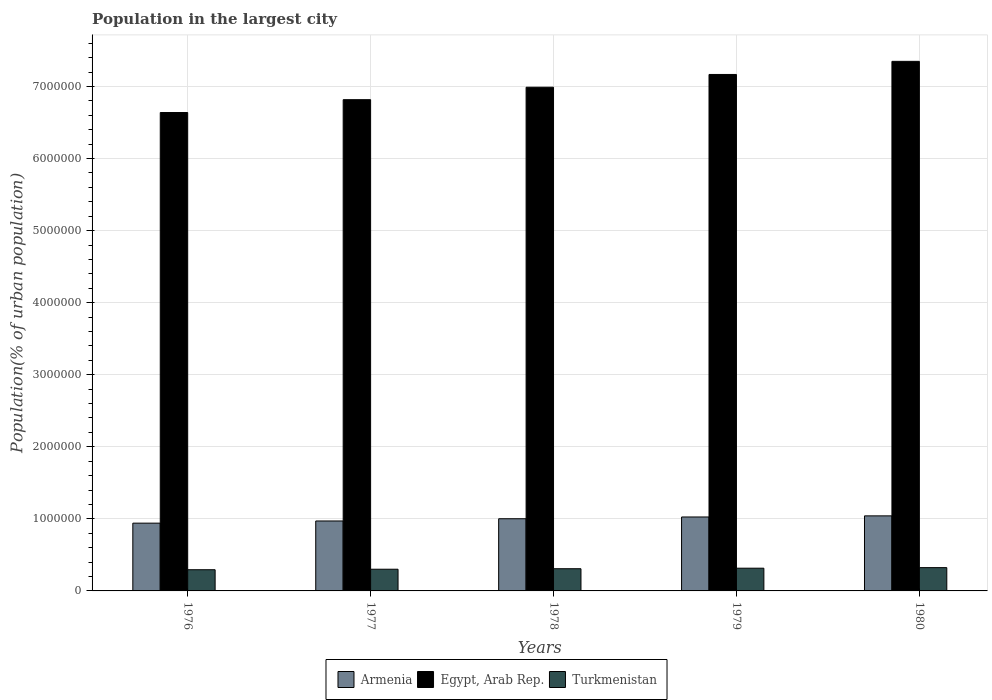How many different coloured bars are there?
Ensure brevity in your answer.  3. How many groups of bars are there?
Make the answer very short. 5. Are the number of bars per tick equal to the number of legend labels?
Your answer should be very brief. Yes. How many bars are there on the 4th tick from the left?
Offer a terse response. 3. How many bars are there on the 2nd tick from the right?
Give a very brief answer. 3. In how many cases, is the number of bars for a given year not equal to the number of legend labels?
Provide a short and direct response. 0. What is the population in the largest city in Turkmenistan in 1978?
Offer a terse response. 3.08e+05. Across all years, what is the maximum population in the largest city in Egypt, Arab Rep.?
Make the answer very short. 7.35e+06. Across all years, what is the minimum population in the largest city in Armenia?
Keep it short and to the point. 9.40e+05. In which year was the population in the largest city in Egypt, Arab Rep. minimum?
Make the answer very short. 1976. What is the total population in the largest city in Egypt, Arab Rep. in the graph?
Give a very brief answer. 3.50e+07. What is the difference between the population in the largest city in Turkmenistan in 1977 and that in 1980?
Offer a terse response. -2.22e+04. What is the difference between the population in the largest city in Turkmenistan in 1977 and the population in the largest city in Armenia in 1976?
Your answer should be very brief. -6.39e+05. What is the average population in the largest city in Egypt, Arab Rep. per year?
Make the answer very short. 6.99e+06. In the year 1976, what is the difference between the population in the largest city in Turkmenistan and population in the largest city in Egypt, Arab Rep.?
Give a very brief answer. -6.34e+06. In how many years, is the population in the largest city in Egypt, Arab Rep. greater than 4200000 %?
Keep it short and to the point. 5. What is the ratio of the population in the largest city in Turkmenistan in 1976 to that in 1978?
Keep it short and to the point. 0.95. Is the difference between the population in the largest city in Turkmenistan in 1976 and 1979 greater than the difference between the population in the largest city in Egypt, Arab Rep. in 1976 and 1979?
Keep it short and to the point. Yes. What is the difference between the highest and the second highest population in the largest city in Armenia?
Provide a succinct answer. 1.56e+04. What is the difference between the highest and the lowest population in the largest city in Egypt, Arab Rep.?
Your response must be concise. 7.10e+05. In how many years, is the population in the largest city in Armenia greater than the average population in the largest city in Armenia taken over all years?
Ensure brevity in your answer.  3. What does the 3rd bar from the left in 1980 represents?
Give a very brief answer. Turkmenistan. What does the 1st bar from the right in 1979 represents?
Offer a very short reply. Turkmenistan. Is it the case that in every year, the sum of the population in the largest city in Armenia and population in the largest city in Egypt, Arab Rep. is greater than the population in the largest city in Turkmenistan?
Give a very brief answer. Yes. Are all the bars in the graph horizontal?
Your answer should be compact. No. Are the values on the major ticks of Y-axis written in scientific E-notation?
Make the answer very short. No. Where does the legend appear in the graph?
Keep it short and to the point. Bottom center. How are the legend labels stacked?
Give a very brief answer. Horizontal. What is the title of the graph?
Your answer should be compact. Population in the largest city. What is the label or title of the X-axis?
Your response must be concise. Years. What is the label or title of the Y-axis?
Ensure brevity in your answer.  Population(% of urban population). What is the Population(% of urban population) in Armenia in 1976?
Your answer should be very brief. 9.40e+05. What is the Population(% of urban population) of Egypt, Arab Rep. in 1976?
Your response must be concise. 6.64e+06. What is the Population(% of urban population) of Turkmenistan in 1976?
Make the answer very short. 2.94e+05. What is the Population(% of urban population) of Armenia in 1977?
Make the answer very short. 9.71e+05. What is the Population(% of urban population) of Egypt, Arab Rep. in 1977?
Offer a very short reply. 6.82e+06. What is the Population(% of urban population) of Turkmenistan in 1977?
Offer a very short reply. 3.01e+05. What is the Population(% of urban population) of Armenia in 1978?
Your answer should be compact. 1.00e+06. What is the Population(% of urban population) of Egypt, Arab Rep. in 1978?
Provide a succinct answer. 6.99e+06. What is the Population(% of urban population) of Turkmenistan in 1978?
Provide a short and direct response. 3.08e+05. What is the Population(% of urban population) in Armenia in 1979?
Your answer should be compact. 1.03e+06. What is the Population(% of urban population) in Egypt, Arab Rep. in 1979?
Keep it short and to the point. 7.17e+06. What is the Population(% of urban population) in Turkmenistan in 1979?
Your answer should be very brief. 3.15e+05. What is the Population(% of urban population) of Armenia in 1980?
Your answer should be very brief. 1.04e+06. What is the Population(% of urban population) in Egypt, Arab Rep. in 1980?
Make the answer very short. 7.35e+06. What is the Population(% of urban population) in Turkmenistan in 1980?
Offer a very short reply. 3.23e+05. Across all years, what is the maximum Population(% of urban population) in Armenia?
Keep it short and to the point. 1.04e+06. Across all years, what is the maximum Population(% of urban population) in Egypt, Arab Rep.?
Offer a terse response. 7.35e+06. Across all years, what is the maximum Population(% of urban population) of Turkmenistan?
Your answer should be compact. 3.23e+05. Across all years, what is the minimum Population(% of urban population) of Armenia?
Offer a terse response. 9.40e+05. Across all years, what is the minimum Population(% of urban population) of Egypt, Arab Rep.?
Ensure brevity in your answer.  6.64e+06. Across all years, what is the minimum Population(% of urban population) in Turkmenistan?
Offer a very short reply. 2.94e+05. What is the total Population(% of urban population) in Armenia in the graph?
Ensure brevity in your answer.  4.98e+06. What is the total Population(% of urban population) in Egypt, Arab Rep. in the graph?
Provide a succinct answer. 3.50e+07. What is the total Population(% of urban population) in Turkmenistan in the graph?
Provide a short and direct response. 1.54e+06. What is the difference between the Population(% of urban population) of Armenia in 1976 and that in 1977?
Give a very brief answer. -3.01e+04. What is the difference between the Population(% of urban population) of Egypt, Arab Rep. in 1976 and that in 1977?
Offer a very short reply. -1.78e+05. What is the difference between the Population(% of urban population) of Turkmenistan in 1976 and that in 1977?
Your answer should be compact. -6919. What is the difference between the Population(% of urban population) of Armenia in 1976 and that in 1978?
Your answer should be compact. -6.12e+04. What is the difference between the Population(% of urban population) of Egypt, Arab Rep. in 1976 and that in 1978?
Your answer should be very brief. -3.51e+05. What is the difference between the Population(% of urban population) of Turkmenistan in 1976 and that in 1978?
Your response must be concise. -1.40e+04. What is the difference between the Population(% of urban population) of Armenia in 1976 and that in 1979?
Provide a succinct answer. -8.56e+04. What is the difference between the Population(% of urban population) of Egypt, Arab Rep. in 1976 and that in 1979?
Your answer should be very brief. -5.28e+05. What is the difference between the Population(% of urban population) in Turkmenistan in 1976 and that in 1979?
Your response must be concise. -2.14e+04. What is the difference between the Population(% of urban population) of Armenia in 1976 and that in 1980?
Offer a terse response. -1.01e+05. What is the difference between the Population(% of urban population) in Egypt, Arab Rep. in 1976 and that in 1980?
Give a very brief answer. -7.10e+05. What is the difference between the Population(% of urban population) of Turkmenistan in 1976 and that in 1980?
Ensure brevity in your answer.  -2.91e+04. What is the difference between the Population(% of urban population) of Armenia in 1977 and that in 1978?
Give a very brief answer. -3.11e+04. What is the difference between the Population(% of urban population) of Egypt, Arab Rep. in 1977 and that in 1978?
Give a very brief answer. -1.73e+05. What is the difference between the Population(% of urban population) of Turkmenistan in 1977 and that in 1978?
Your answer should be very brief. -7093. What is the difference between the Population(% of urban population) in Armenia in 1977 and that in 1979?
Give a very brief answer. -5.55e+04. What is the difference between the Population(% of urban population) in Egypt, Arab Rep. in 1977 and that in 1979?
Provide a short and direct response. -3.50e+05. What is the difference between the Population(% of urban population) of Turkmenistan in 1977 and that in 1979?
Ensure brevity in your answer.  -1.45e+04. What is the difference between the Population(% of urban population) of Armenia in 1977 and that in 1980?
Offer a terse response. -7.10e+04. What is the difference between the Population(% of urban population) of Egypt, Arab Rep. in 1977 and that in 1980?
Keep it short and to the point. -5.32e+05. What is the difference between the Population(% of urban population) of Turkmenistan in 1977 and that in 1980?
Give a very brief answer. -2.22e+04. What is the difference between the Population(% of urban population) in Armenia in 1978 and that in 1979?
Your response must be concise. -2.43e+04. What is the difference between the Population(% of urban population) in Egypt, Arab Rep. in 1978 and that in 1979?
Keep it short and to the point. -1.77e+05. What is the difference between the Population(% of urban population) of Turkmenistan in 1978 and that in 1979?
Give a very brief answer. -7389. What is the difference between the Population(% of urban population) of Armenia in 1978 and that in 1980?
Keep it short and to the point. -3.99e+04. What is the difference between the Population(% of urban population) of Egypt, Arab Rep. in 1978 and that in 1980?
Give a very brief answer. -3.59e+05. What is the difference between the Population(% of urban population) in Turkmenistan in 1978 and that in 1980?
Your response must be concise. -1.51e+04. What is the difference between the Population(% of urban population) of Armenia in 1979 and that in 1980?
Provide a succinct answer. -1.56e+04. What is the difference between the Population(% of urban population) of Egypt, Arab Rep. in 1979 and that in 1980?
Provide a short and direct response. -1.82e+05. What is the difference between the Population(% of urban population) in Turkmenistan in 1979 and that in 1980?
Offer a very short reply. -7733. What is the difference between the Population(% of urban population) in Armenia in 1976 and the Population(% of urban population) in Egypt, Arab Rep. in 1977?
Provide a succinct answer. -5.88e+06. What is the difference between the Population(% of urban population) of Armenia in 1976 and the Population(% of urban population) of Turkmenistan in 1977?
Your answer should be very brief. 6.39e+05. What is the difference between the Population(% of urban population) of Egypt, Arab Rep. in 1976 and the Population(% of urban population) of Turkmenistan in 1977?
Your answer should be compact. 6.34e+06. What is the difference between the Population(% of urban population) of Armenia in 1976 and the Population(% of urban population) of Egypt, Arab Rep. in 1978?
Keep it short and to the point. -6.05e+06. What is the difference between the Population(% of urban population) of Armenia in 1976 and the Population(% of urban population) of Turkmenistan in 1978?
Make the answer very short. 6.32e+05. What is the difference between the Population(% of urban population) of Egypt, Arab Rep. in 1976 and the Population(% of urban population) of Turkmenistan in 1978?
Offer a terse response. 6.33e+06. What is the difference between the Population(% of urban population) in Armenia in 1976 and the Population(% of urban population) in Egypt, Arab Rep. in 1979?
Ensure brevity in your answer.  -6.23e+06. What is the difference between the Population(% of urban population) in Armenia in 1976 and the Population(% of urban population) in Turkmenistan in 1979?
Give a very brief answer. 6.25e+05. What is the difference between the Population(% of urban population) of Egypt, Arab Rep. in 1976 and the Population(% of urban population) of Turkmenistan in 1979?
Your response must be concise. 6.32e+06. What is the difference between the Population(% of urban population) of Armenia in 1976 and the Population(% of urban population) of Egypt, Arab Rep. in 1980?
Give a very brief answer. -6.41e+06. What is the difference between the Population(% of urban population) in Armenia in 1976 and the Population(% of urban population) in Turkmenistan in 1980?
Offer a terse response. 6.17e+05. What is the difference between the Population(% of urban population) of Egypt, Arab Rep. in 1976 and the Population(% of urban population) of Turkmenistan in 1980?
Provide a succinct answer. 6.32e+06. What is the difference between the Population(% of urban population) in Armenia in 1977 and the Population(% of urban population) in Egypt, Arab Rep. in 1978?
Your answer should be compact. -6.02e+06. What is the difference between the Population(% of urban population) in Armenia in 1977 and the Population(% of urban population) in Turkmenistan in 1978?
Your response must be concise. 6.62e+05. What is the difference between the Population(% of urban population) of Egypt, Arab Rep. in 1977 and the Population(% of urban population) of Turkmenistan in 1978?
Your answer should be very brief. 6.51e+06. What is the difference between the Population(% of urban population) of Armenia in 1977 and the Population(% of urban population) of Egypt, Arab Rep. in 1979?
Offer a very short reply. -6.20e+06. What is the difference between the Population(% of urban population) in Armenia in 1977 and the Population(% of urban population) in Turkmenistan in 1979?
Offer a terse response. 6.55e+05. What is the difference between the Population(% of urban population) in Egypt, Arab Rep. in 1977 and the Population(% of urban population) in Turkmenistan in 1979?
Your answer should be compact. 6.50e+06. What is the difference between the Population(% of urban population) of Armenia in 1977 and the Population(% of urban population) of Egypt, Arab Rep. in 1980?
Give a very brief answer. -6.38e+06. What is the difference between the Population(% of urban population) of Armenia in 1977 and the Population(% of urban population) of Turkmenistan in 1980?
Keep it short and to the point. 6.47e+05. What is the difference between the Population(% of urban population) of Egypt, Arab Rep. in 1977 and the Population(% of urban population) of Turkmenistan in 1980?
Your answer should be very brief. 6.49e+06. What is the difference between the Population(% of urban population) in Armenia in 1978 and the Population(% of urban population) in Egypt, Arab Rep. in 1979?
Provide a succinct answer. -6.17e+06. What is the difference between the Population(% of urban population) in Armenia in 1978 and the Population(% of urban population) in Turkmenistan in 1979?
Give a very brief answer. 6.86e+05. What is the difference between the Population(% of urban population) of Egypt, Arab Rep. in 1978 and the Population(% of urban population) of Turkmenistan in 1979?
Make the answer very short. 6.67e+06. What is the difference between the Population(% of urban population) of Armenia in 1978 and the Population(% of urban population) of Egypt, Arab Rep. in 1980?
Offer a terse response. -6.35e+06. What is the difference between the Population(% of urban population) in Armenia in 1978 and the Population(% of urban population) in Turkmenistan in 1980?
Your response must be concise. 6.78e+05. What is the difference between the Population(% of urban population) in Egypt, Arab Rep. in 1978 and the Population(% of urban population) in Turkmenistan in 1980?
Your answer should be very brief. 6.67e+06. What is the difference between the Population(% of urban population) of Armenia in 1979 and the Population(% of urban population) of Egypt, Arab Rep. in 1980?
Your answer should be very brief. -6.32e+06. What is the difference between the Population(% of urban population) in Armenia in 1979 and the Population(% of urban population) in Turkmenistan in 1980?
Your response must be concise. 7.03e+05. What is the difference between the Population(% of urban population) of Egypt, Arab Rep. in 1979 and the Population(% of urban population) of Turkmenistan in 1980?
Your answer should be compact. 6.84e+06. What is the average Population(% of urban population) of Armenia per year?
Provide a short and direct response. 9.96e+05. What is the average Population(% of urban population) of Egypt, Arab Rep. per year?
Offer a terse response. 6.99e+06. What is the average Population(% of urban population) of Turkmenistan per year?
Keep it short and to the point. 3.08e+05. In the year 1976, what is the difference between the Population(% of urban population) in Armenia and Population(% of urban population) in Egypt, Arab Rep.?
Provide a succinct answer. -5.70e+06. In the year 1976, what is the difference between the Population(% of urban population) of Armenia and Population(% of urban population) of Turkmenistan?
Offer a very short reply. 6.46e+05. In the year 1976, what is the difference between the Population(% of urban population) in Egypt, Arab Rep. and Population(% of urban population) in Turkmenistan?
Your answer should be compact. 6.34e+06. In the year 1977, what is the difference between the Population(% of urban population) of Armenia and Population(% of urban population) of Egypt, Arab Rep.?
Your response must be concise. -5.85e+06. In the year 1977, what is the difference between the Population(% of urban population) in Armenia and Population(% of urban population) in Turkmenistan?
Offer a very short reply. 6.70e+05. In the year 1977, what is the difference between the Population(% of urban population) in Egypt, Arab Rep. and Population(% of urban population) in Turkmenistan?
Provide a succinct answer. 6.52e+06. In the year 1978, what is the difference between the Population(% of urban population) of Armenia and Population(% of urban population) of Egypt, Arab Rep.?
Ensure brevity in your answer.  -5.99e+06. In the year 1978, what is the difference between the Population(% of urban population) in Armenia and Population(% of urban population) in Turkmenistan?
Give a very brief answer. 6.94e+05. In the year 1978, what is the difference between the Population(% of urban population) in Egypt, Arab Rep. and Population(% of urban population) in Turkmenistan?
Your answer should be compact. 6.68e+06. In the year 1979, what is the difference between the Population(% of urban population) in Armenia and Population(% of urban population) in Egypt, Arab Rep.?
Make the answer very short. -6.14e+06. In the year 1979, what is the difference between the Population(% of urban population) of Armenia and Population(% of urban population) of Turkmenistan?
Give a very brief answer. 7.11e+05. In the year 1979, what is the difference between the Population(% of urban population) of Egypt, Arab Rep. and Population(% of urban population) of Turkmenistan?
Ensure brevity in your answer.  6.85e+06. In the year 1980, what is the difference between the Population(% of urban population) of Armenia and Population(% of urban population) of Egypt, Arab Rep.?
Ensure brevity in your answer.  -6.31e+06. In the year 1980, what is the difference between the Population(% of urban population) in Armenia and Population(% of urban population) in Turkmenistan?
Your response must be concise. 7.18e+05. In the year 1980, what is the difference between the Population(% of urban population) of Egypt, Arab Rep. and Population(% of urban population) of Turkmenistan?
Your answer should be compact. 7.03e+06. What is the ratio of the Population(% of urban population) of Egypt, Arab Rep. in 1976 to that in 1977?
Provide a short and direct response. 0.97. What is the ratio of the Population(% of urban population) in Turkmenistan in 1976 to that in 1977?
Give a very brief answer. 0.98. What is the ratio of the Population(% of urban population) of Armenia in 1976 to that in 1978?
Provide a succinct answer. 0.94. What is the ratio of the Population(% of urban population) of Egypt, Arab Rep. in 1976 to that in 1978?
Your answer should be very brief. 0.95. What is the ratio of the Population(% of urban population) of Turkmenistan in 1976 to that in 1978?
Ensure brevity in your answer.  0.95. What is the ratio of the Population(% of urban population) of Armenia in 1976 to that in 1979?
Make the answer very short. 0.92. What is the ratio of the Population(% of urban population) in Egypt, Arab Rep. in 1976 to that in 1979?
Provide a short and direct response. 0.93. What is the ratio of the Population(% of urban population) in Turkmenistan in 1976 to that in 1979?
Provide a short and direct response. 0.93. What is the ratio of the Population(% of urban population) of Armenia in 1976 to that in 1980?
Offer a terse response. 0.9. What is the ratio of the Population(% of urban population) of Egypt, Arab Rep. in 1976 to that in 1980?
Give a very brief answer. 0.9. What is the ratio of the Population(% of urban population) of Turkmenistan in 1976 to that in 1980?
Provide a succinct answer. 0.91. What is the ratio of the Population(% of urban population) of Armenia in 1977 to that in 1978?
Your answer should be compact. 0.97. What is the ratio of the Population(% of urban population) in Egypt, Arab Rep. in 1977 to that in 1978?
Keep it short and to the point. 0.98. What is the ratio of the Population(% of urban population) of Turkmenistan in 1977 to that in 1978?
Provide a short and direct response. 0.98. What is the ratio of the Population(% of urban population) in Armenia in 1977 to that in 1979?
Make the answer very short. 0.95. What is the ratio of the Population(% of urban population) of Egypt, Arab Rep. in 1977 to that in 1979?
Provide a short and direct response. 0.95. What is the ratio of the Population(% of urban population) in Turkmenistan in 1977 to that in 1979?
Provide a short and direct response. 0.95. What is the ratio of the Population(% of urban population) of Armenia in 1977 to that in 1980?
Offer a very short reply. 0.93. What is the ratio of the Population(% of urban population) of Egypt, Arab Rep. in 1977 to that in 1980?
Your answer should be compact. 0.93. What is the ratio of the Population(% of urban population) in Turkmenistan in 1977 to that in 1980?
Your answer should be compact. 0.93. What is the ratio of the Population(% of urban population) in Armenia in 1978 to that in 1979?
Offer a terse response. 0.98. What is the ratio of the Population(% of urban population) in Egypt, Arab Rep. in 1978 to that in 1979?
Make the answer very short. 0.98. What is the ratio of the Population(% of urban population) in Turkmenistan in 1978 to that in 1979?
Your answer should be very brief. 0.98. What is the ratio of the Population(% of urban population) of Armenia in 1978 to that in 1980?
Make the answer very short. 0.96. What is the ratio of the Population(% of urban population) in Egypt, Arab Rep. in 1978 to that in 1980?
Keep it short and to the point. 0.95. What is the ratio of the Population(% of urban population) of Turkmenistan in 1978 to that in 1980?
Provide a succinct answer. 0.95. What is the ratio of the Population(% of urban population) in Armenia in 1979 to that in 1980?
Offer a terse response. 0.99. What is the ratio of the Population(% of urban population) of Egypt, Arab Rep. in 1979 to that in 1980?
Provide a succinct answer. 0.98. What is the ratio of the Population(% of urban population) of Turkmenistan in 1979 to that in 1980?
Provide a succinct answer. 0.98. What is the difference between the highest and the second highest Population(% of urban population) in Armenia?
Ensure brevity in your answer.  1.56e+04. What is the difference between the highest and the second highest Population(% of urban population) in Egypt, Arab Rep.?
Keep it short and to the point. 1.82e+05. What is the difference between the highest and the second highest Population(% of urban population) in Turkmenistan?
Offer a very short reply. 7733. What is the difference between the highest and the lowest Population(% of urban population) of Armenia?
Your response must be concise. 1.01e+05. What is the difference between the highest and the lowest Population(% of urban population) in Egypt, Arab Rep.?
Ensure brevity in your answer.  7.10e+05. What is the difference between the highest and the lowest Population(% of urban population) in Turkmenistan?
Your answer should be very brief. 2.91e+04. 